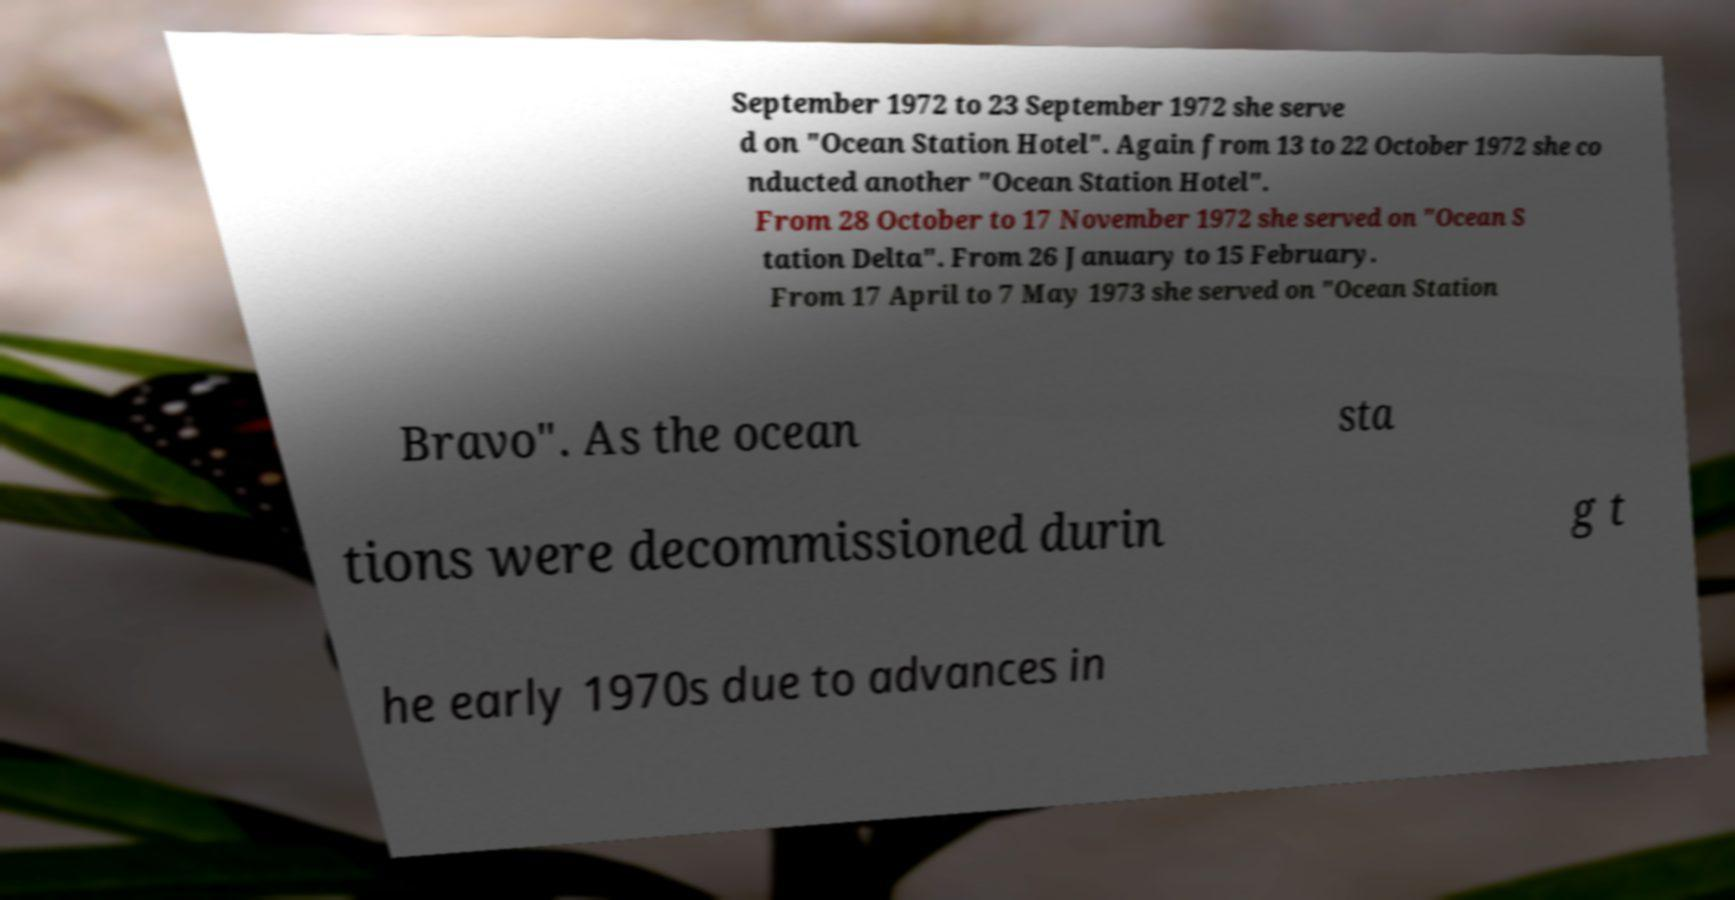Can you accurately transcribe the text from the provided image for me? September 1972 to 23 September 1972 she serve d on "Ocean Station Hotel". Again from 13 to 22 October 1972 she co nducted another "Ocean Station Hotel". From 28 October to 17 November 1972 she served on "Ocean S tation Delta". From 26 January to 15 February. From 17 April to 7 May 1973 she served on "Ocean Station Bravo". As the ocean sta tions were decommissioned durin g t he early 1970s due to advances in 